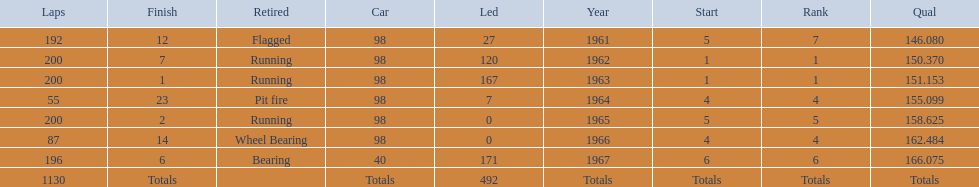How many total laps have been driven in the indy 500? 1130. Could you parse the entire table as a dict? {'header': ['Laps', 'Finish', 'Retired', 'Car', 'Led', 'Year', 'Start', 'Rank', 'Qual'], 'rows': [['192', '12', 'Flagged', '98', '27', '1961', '5', '7', '146.080'], ['200', '7', 'Running', '98', '120', '1962', '1', '1', '150.370'], ['200', '1', 'Running', '98', '167', '1963', '1', '1', '151.153'], ['55', '23', 'Pit fire', '98', '7', '1964', '4', '4', '155.099'], ['200', '2', 'Running', '98', '0', '1965', '5', '5', '158.625'], ['87', '14', 'Wheel Bearing', '98', '0', '1966', '4', '4', '162.484'], ['196', '6', 'Bearing', '40', '171', '1967', '6', '6', '166.075'], ['1130', 'Totals', '', 'Totals', '492', 'Totals', 'Totals', 'Totals', 'Totals']]} 